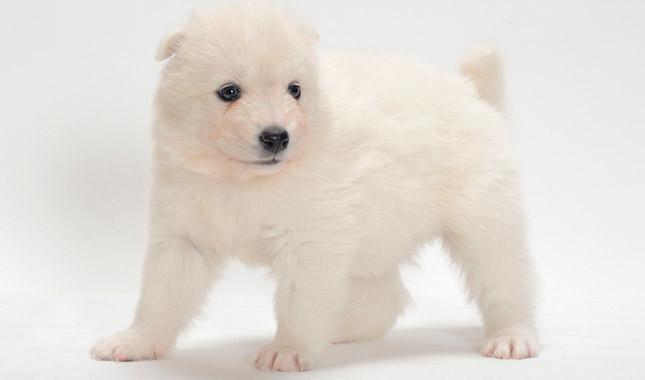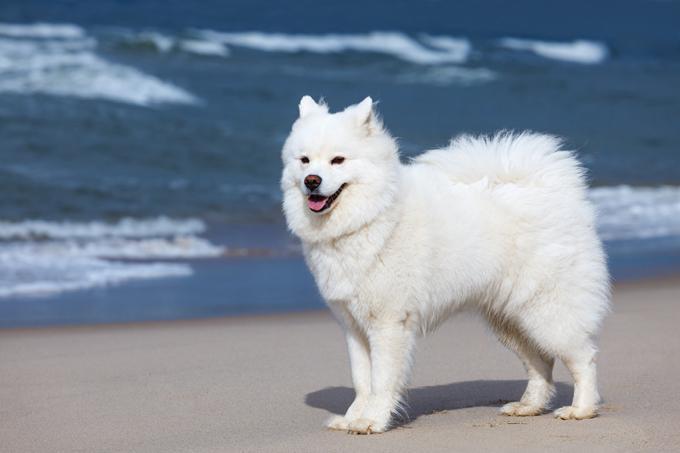The first image is the image on the left, the second image is the image on the right. Considering the images on both sides, is "At least two dogs have have visible tongues." valid? Answer yes or no. No. 